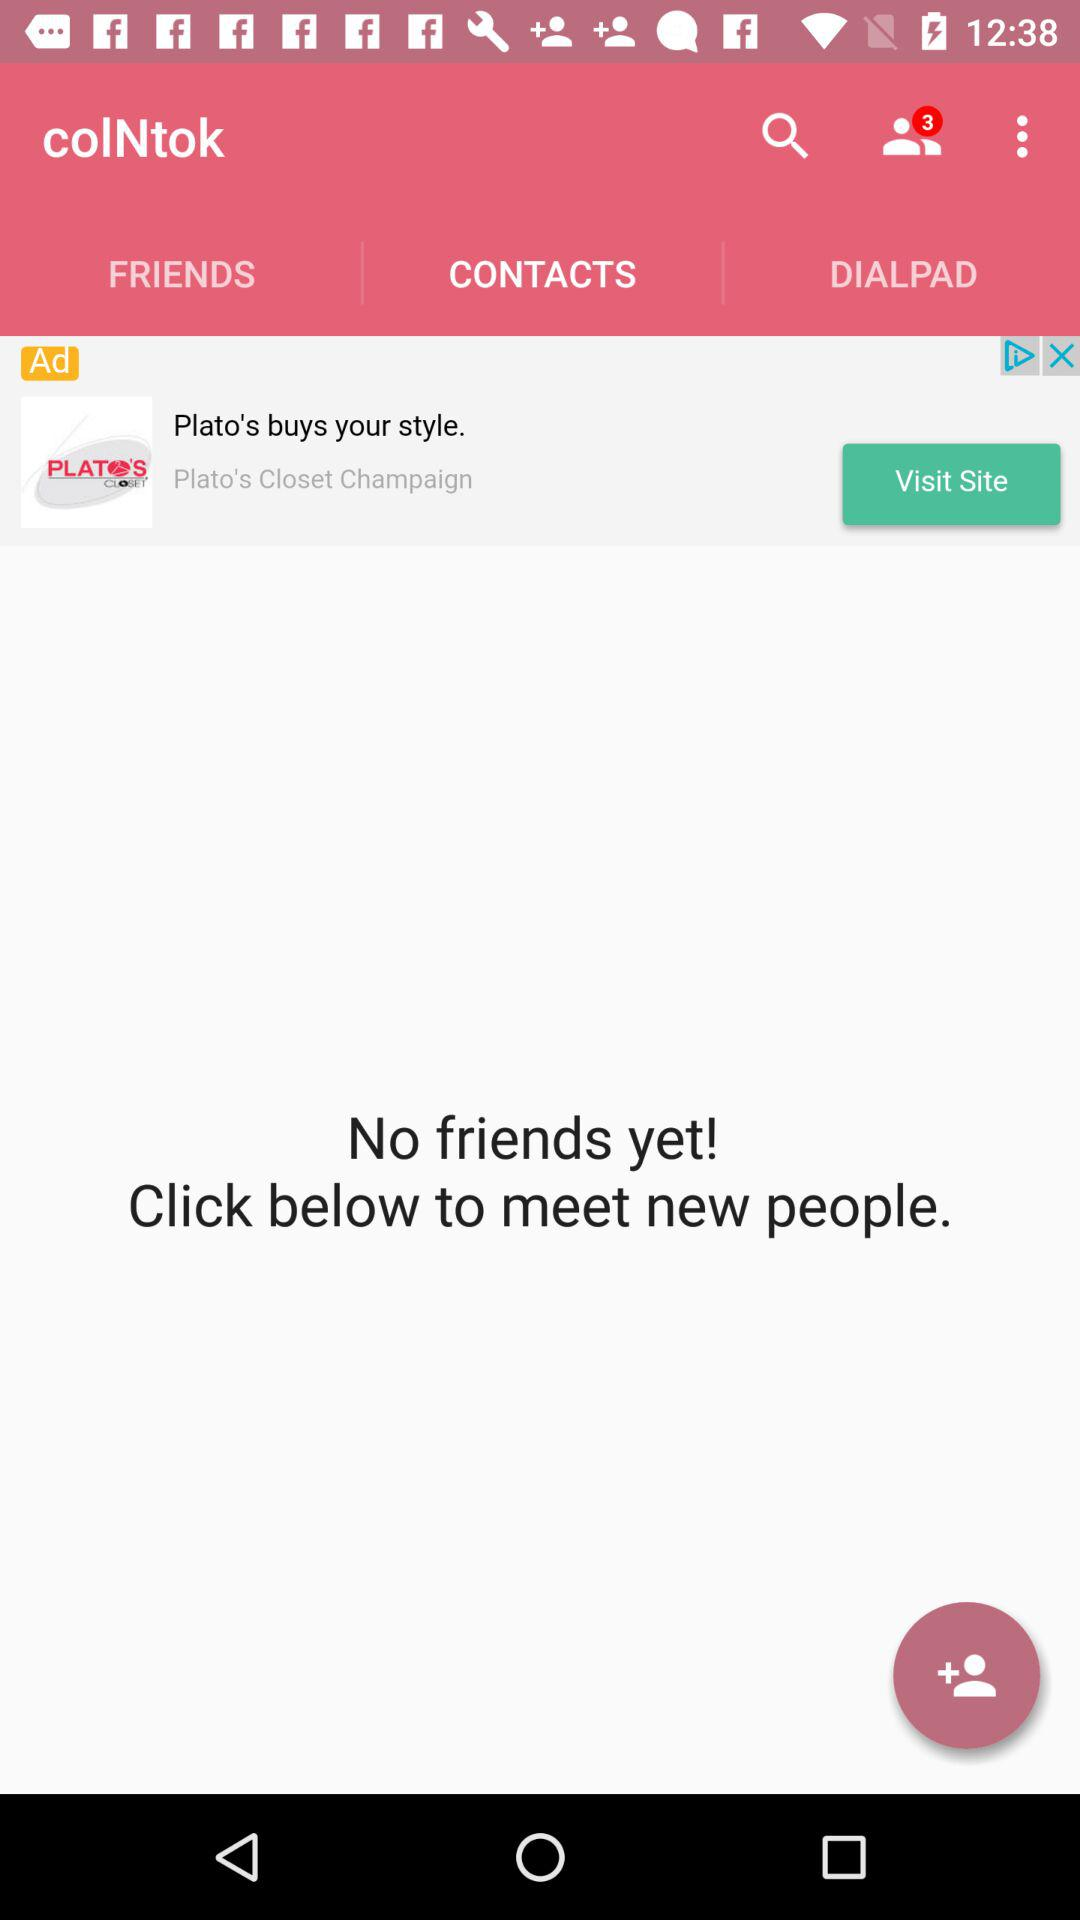What is the application name? The application name is "colNtok". 